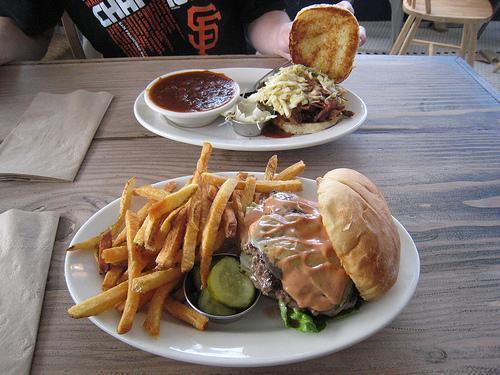How many plates of food are there?
Give a very brief answer. 2. How many white plates are visible?
Give a very brief answer. 2. How many hamburgers are shown?
Give a very brief answer. 2. 